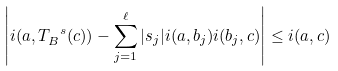Convert formula to latex. <formula><loc_0><loc_0><loc_500><loc_500>\left | i ( a , T _ { B } ^ { \ s } ( c ) ) - \sum _ { j = 1 } ^ { \ell } | s _ { j } | i ( a , b _ { j } ) i ( b _ { j } , c ) \right | \leq i ( a , c )</formula> 